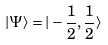Convert formula to latex. <formula><loc_0><loc_0><loc_500><loc_500>| \Psi \rangle = | - \frac { 1 } { 2 } , \frac { 1 } { 2 } \rangle</formula> 